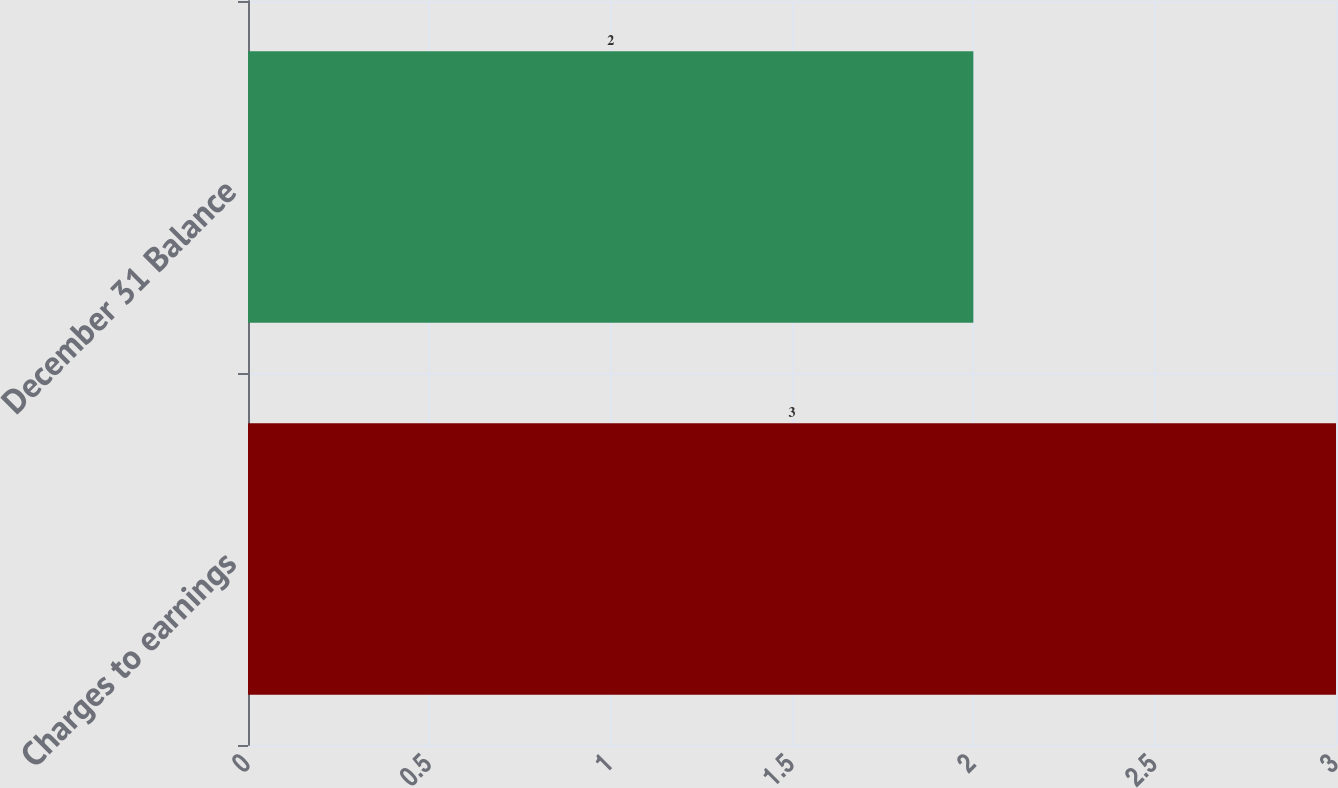Convert chart. <chart><loc_0><loc_0><loc_500><loc_500><bar_chart><fcel>Charges to earnings<fcel>December 31 Balance<nl><fcel>3<fcel>2<nl></chart> 